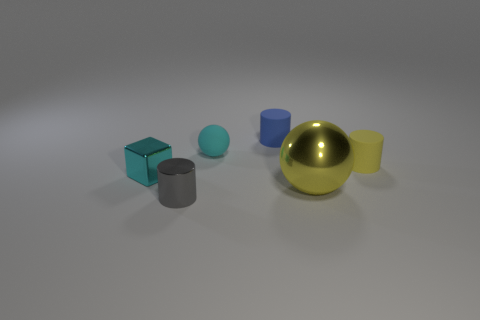Add 4 blue matte cylinders. How many objects exist? 10 Subtract all balls. How many objects are left? 4 Subtract all tiny gray metallic balls. Subtract all metal things. How many objects are left? 3 Add 4 yellow shiny objects. How many yellow shiny objects are left? 5 Add 2 shiny cylinders. How many shiny cylinders exist? 3 Subtract 0 green spheres. How many objects are left? 6 